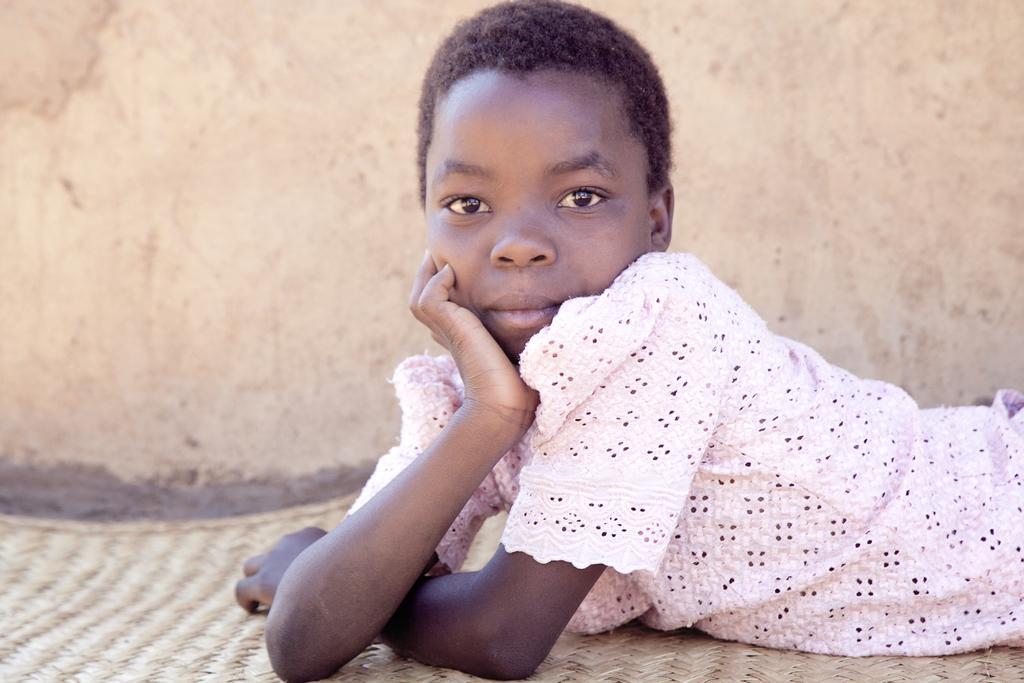In one or two sentences, can you explain what this image depicts? In the image there is a girl in pink shirt laying on floor and behind her there is a wall. 